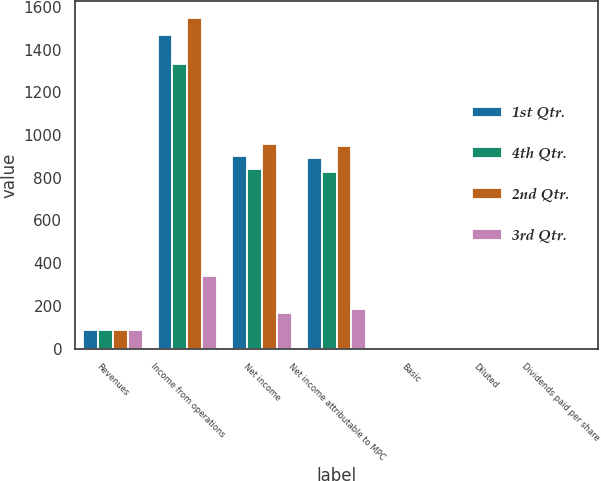<chart> <loc_0><loc_0><loc_500><loc_500><stacked_bar_chart><ecel><fcel>Revenues<fcel>Income from operations<fcel>Net income<fcel>Net income attributable to MPC<fcel>Basic<fcel>Diluted<fcel>Dividends paid per share<nl><fcel>1st Qtr.<fcel>84.885<fcel>1470<fcel>903<fcel>891<fcel>1.63<fcel>1.62<fcel>0.25<nl><fcel>4th Qtr.<fcel>84.885<fcel>1335<fcel>839<fcel>826<fcel>1.52<fcel>1.51<fcel>0.25<nl><fcel>2nd Qtr.<fcel>84.885<fcel>1549<fcel>958<fcel>948<fcel>1.77<fcel>1.76<fcel>0.32<nl><fcel>3rd Qtr.<fcel>84.885<fcel>338<fcel>168<fcel>187<fcel>0.35<fcel>0.35<fcel>0.32<nl></chart> 